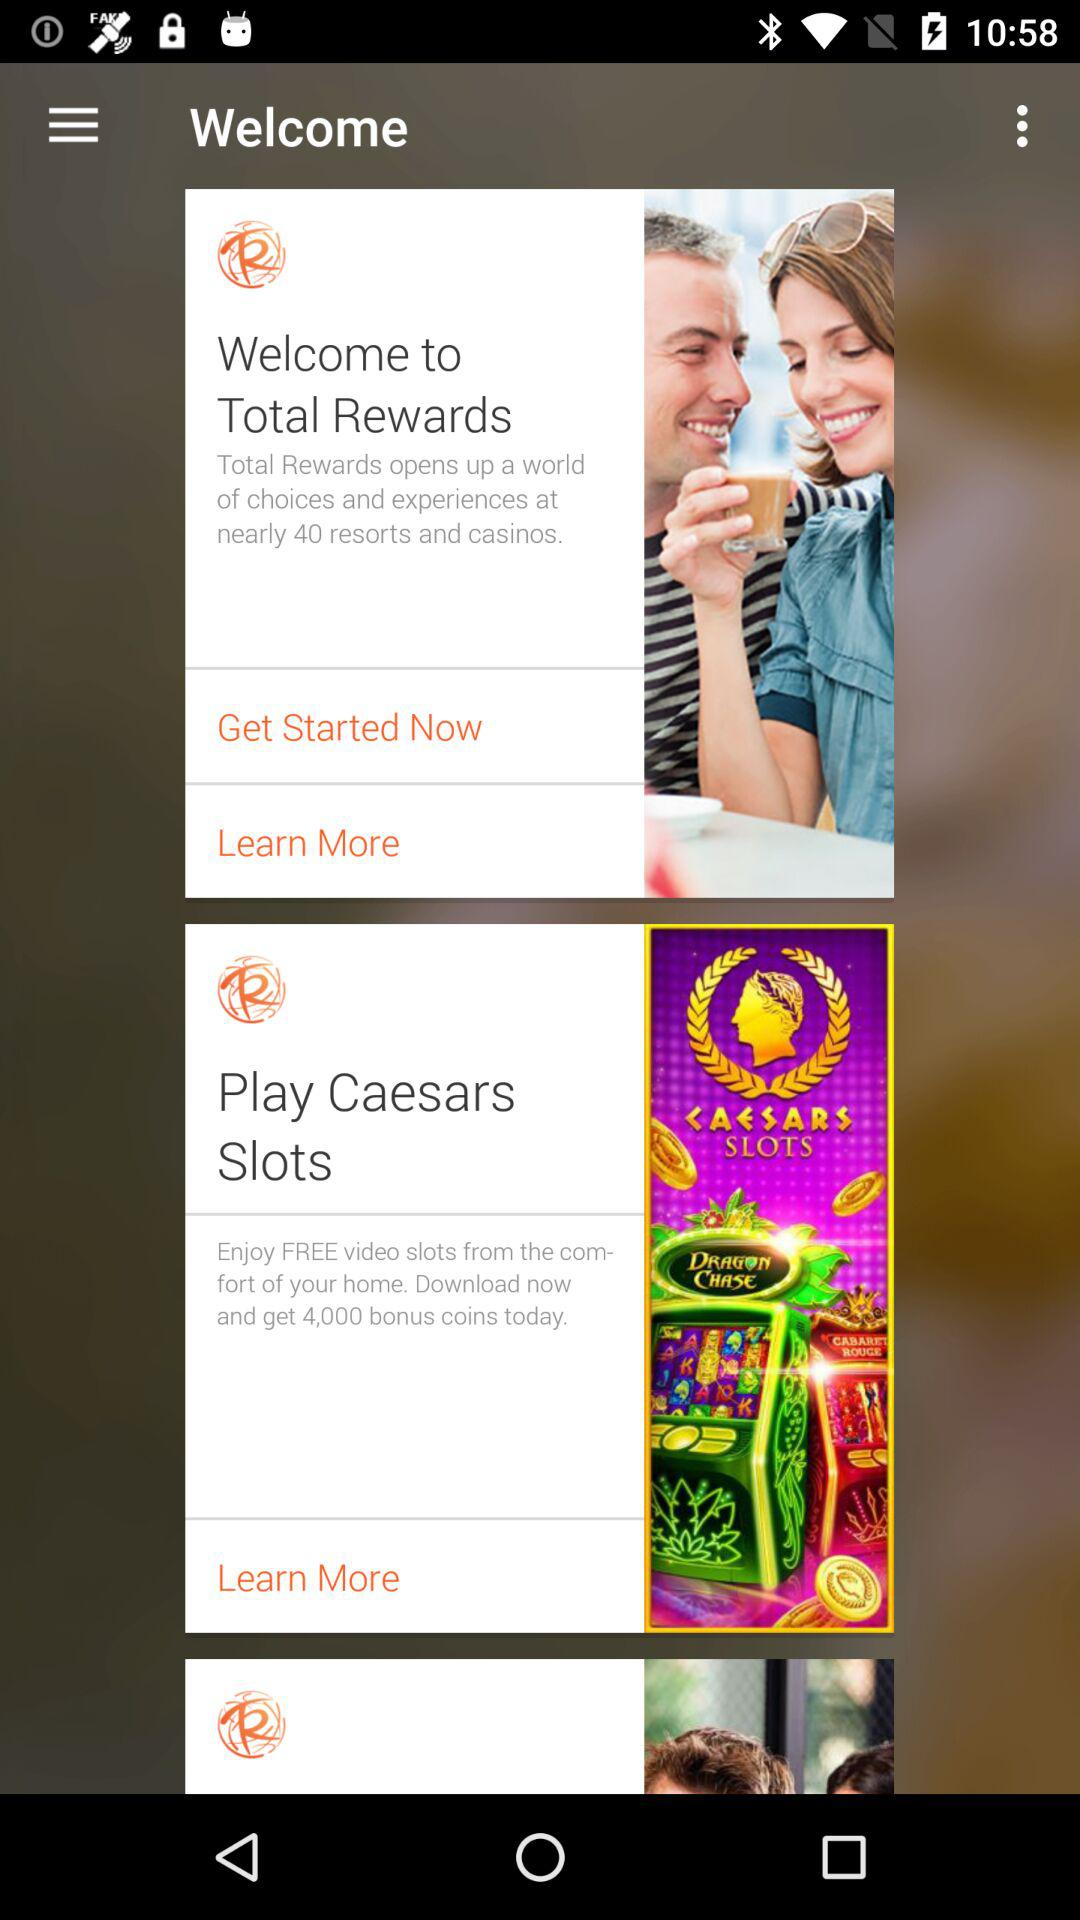How many resorts and casinos are mentioned? There are 40 resorts and casinos are mentioned. 